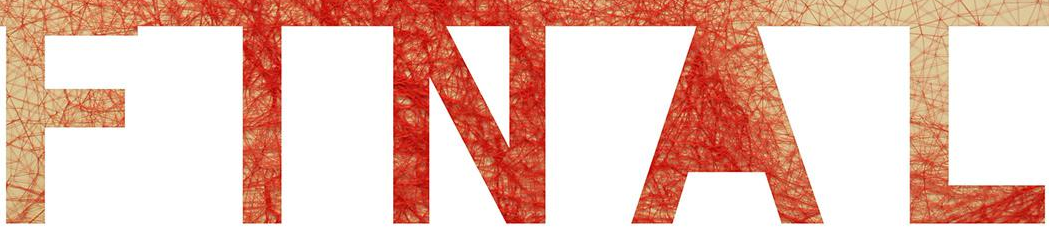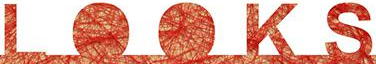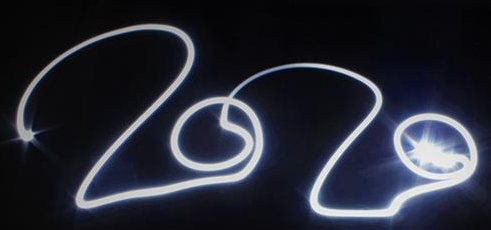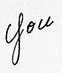Identify the words shown in these images in order, separated by a semicolon. FINAL; LOOKS; 2020; you 